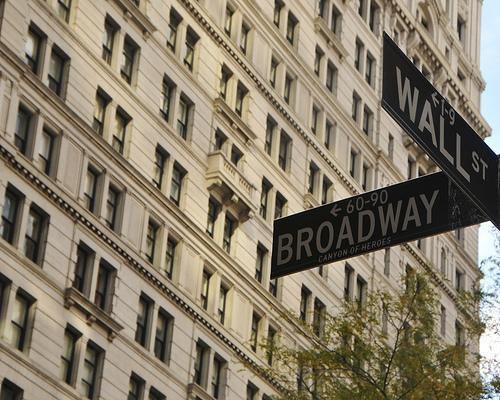How many windows have balconies?
Give a very brief answer. 1. 